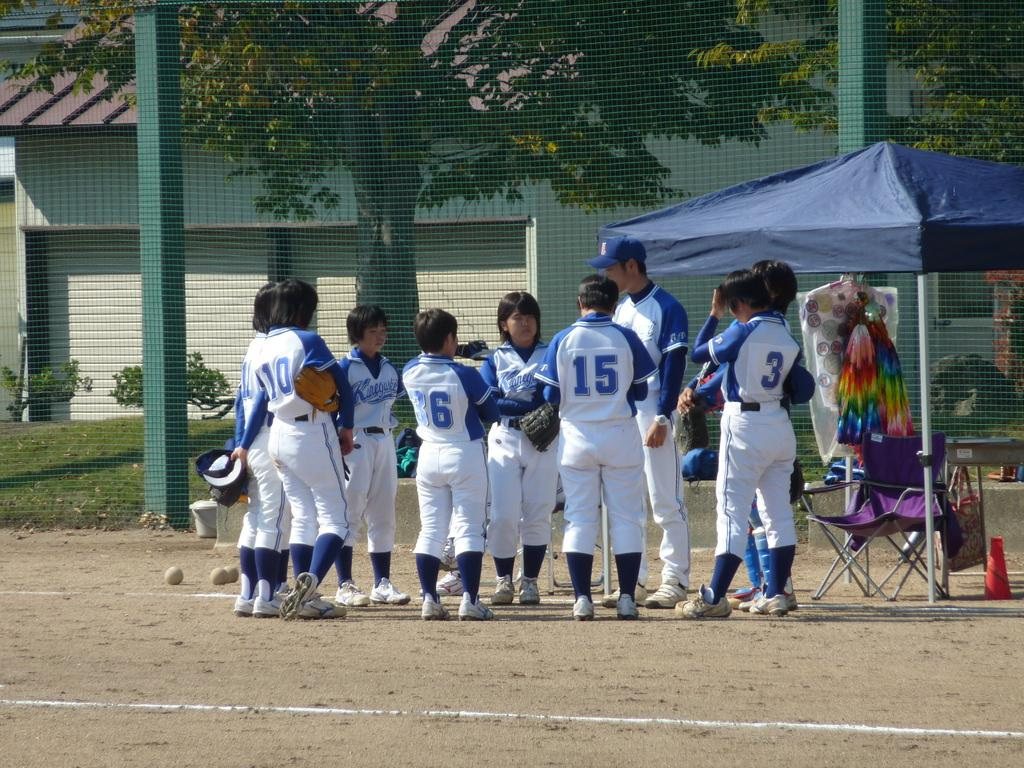Provide a one-sentence caption for the provided image. A group of baseball players that number 15 is apart of. 